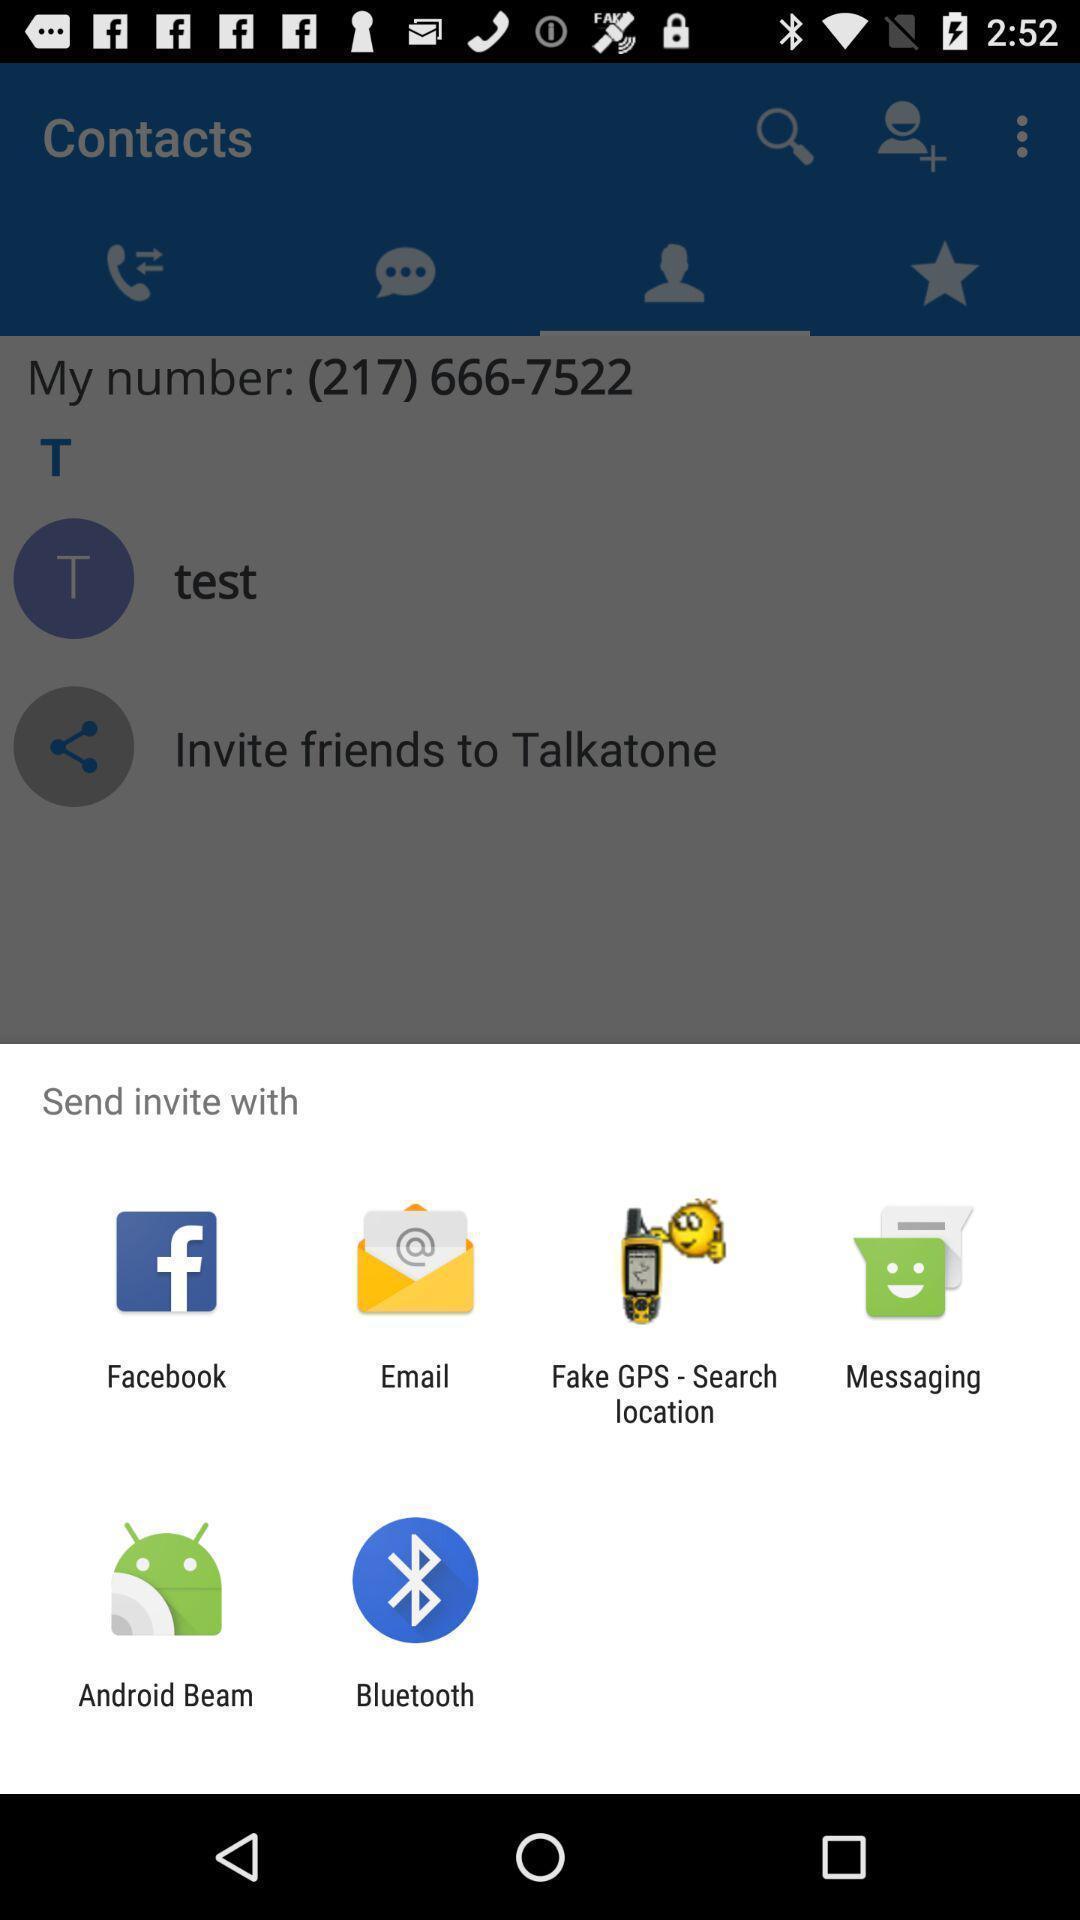Give me a narrative description of this picture. Pop-up showing different options to send. 